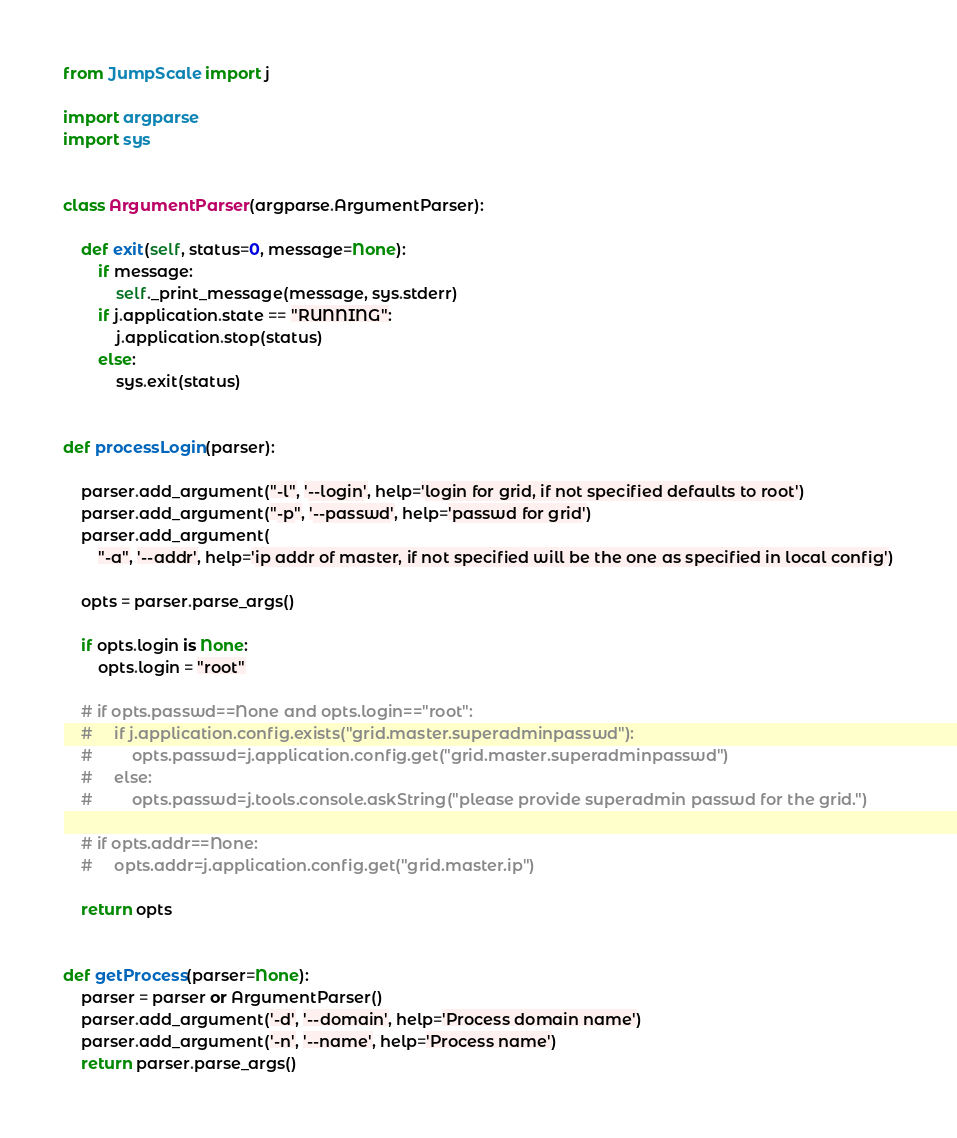<code> <loc_0><loc_0><loc_500><loc_500><_Python_>from JumpScale import j

import argparse
import sys


class ArgumentParser(argparse.ArgumentParser):

    def exit(self, status=0, message=None):
        if message:
            self._print_message(message, sys.stderr)
        if j.application.state == "RUNNING":
            j.application.stop(status)
        else:
            sys.exit(status)


def processLogin(parser):

    parser.add_argument("-l", '--login', help='login for grid, if not specified defaults to root')
    parser.add_argument("-p", '--passwd', help='passwd for grid')
    parser.add_argument(
        "-a", '--addr', help='ip addr of master, if not specified will be the one as specified in local config')

    opts = parser.parse_args()

    if opts.login is None:
        opts.login = "root"

    # if opts.passwd==None and opts.login=="root":
    #     if j.application.config.exists("grid.master.superadminpasswd"):
    #         opts.passwd=j.application.config.get("grid.master.superadminpasswd")
    #     else:
    #         opts.passwd=j.tools.console.askString("please provide superadmin passwd for the grid.")

    # if opts.addr==None:
    #     opts.addr=j.application.config.get("grid.master.ip")

    return opts


def getProcess(parser=None):
    parser = parser or ArgumentParser()
    parser.add_argument('-d', '--domain', help='Process domain name')
    parser.add_argument('-n', '--name', help='Process name')
    return parser.parse_args()
</code> 